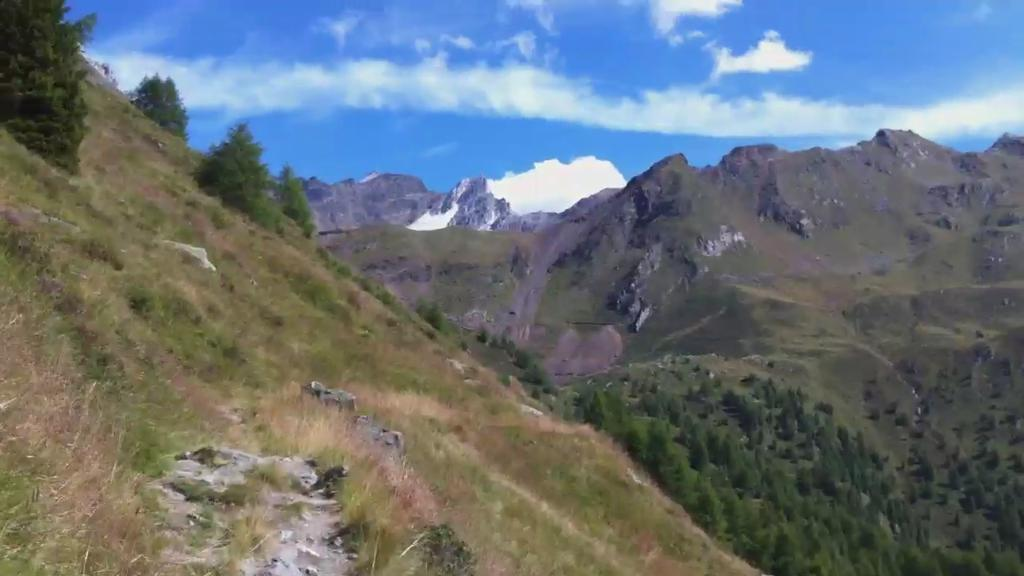What type of vegetation can be seen in the image? There are trees in the image. What else can be seen on the ground in the image? There is grass in the image. What type of geographical feature is visible in the image? There are mountains in the image. What is visible in the background of the image? The sky is visible in the background of the image. What type of language is spoken by the trees in the image? Trees do not speak any language, so this question cannot be answered. What type of grain is visible in the image? There is no grain present in the image. 